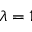<formula> <loc_0><loc_0><loc_500><loc_500>\lambda = 1</formula> 